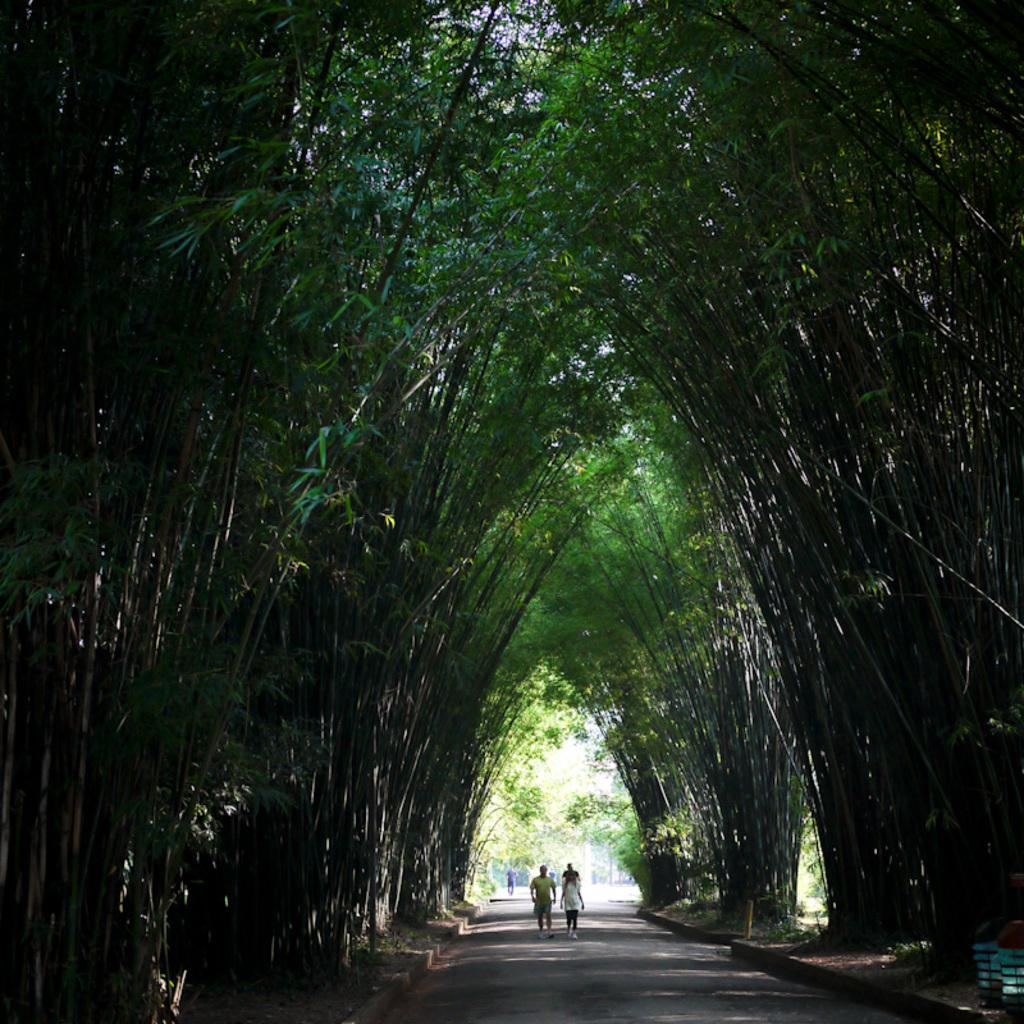Where was the picture taken? The picture was taken outside. What is the main subject of the image? There is a group of people in the center of the image. What type of natural environment can be seen in the image? There are trees visible in the image. Can you describe any other objects or features in the image? There are other unspecified items in the image. What type of scale is being used by the people in the image? There is no scale present in the image; it features a group of people and trees. What color is the skirt worn by the person on the left side of the image? There is no person wearing a skirt in the image; it features a group of people and trees. 